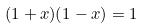Convert formula to latex. <formula><loc_0><loc_0><loc_500><loc_500>( 1 + x ) ( 1 - x ) = 1</formula> 